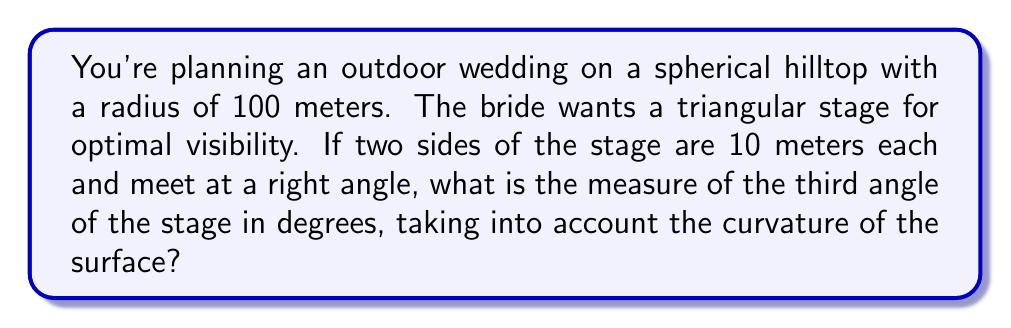Could you help me with this problem? Let's approach this step-by-step using spherical geometry:

1) In spherical geometry, the sum of angles in a triangle is greater than 180°. The excess is given by the formula:

   $$E = A + B + C - 180°$$

   where $E$ is the spherical excess and $A$, $B$, and $C$ are the angles of the triangle.

2) The spherical excess is related to the area of the triangle and the radius of the sphere:

   $$E = \frac{Area}{R^2}$$ (in radians)

3) We can calculate the area of our triangle using L'Huilier's formula:
   
   $$\tan(\frac{E}{4}) = \sqrt{\tan(\frac{s}{2})\tan(\frac{s-a}{2})\tan(\frac{s-b}{2})\tan(\frac{s-c}{2})}$$

   where $s = \frac{a+b+c}{2}$ is the semi-perimeter, and $a$, $b$, and $c$ are the side lengths.

4) We know two sides are 10m each, and they meet at a right angle. To find the third side, we use the spherical Pythagorean theorem:

   $$\cos(c) = \cos(a)\cos(b)$$

   where $a$, $b$, and $c$ are the side lengths divided by the radius.

5) $$\cos(\frac{c}{100}) = \cos(\frac{10}{100})\cos(\frac{10}{100}) \approx 0.9801$$

6) $$c \approx 12.78m$$

7) Now we can calculate $s$:

   $$s = \frac{10 + 10 + 12.78}{2} = 16.39m$$

8) Plugging into L'Huilier's formula:

   $$\tan(\frac{E}{4}) = \sqrt{\tan(\frac{16.39}{200})\tan(\frac{6.39}{200})\tan(\frac{6.39}{200})\tan(\frac{3.61}{200})} \approx 0.0252$$

9) $$E \approx 0.1008 \text{ radians} = 5.78°$$

10) We know one angle is 90°, so if we call our unknown angle $x$:

    $$90° + 90° + x + 5.78° = 360°$$

11) Solving for $x$:

    $$x = 360° - 90° - 90° - 5.78° = 174.22°$$
Answer: 174.22° 